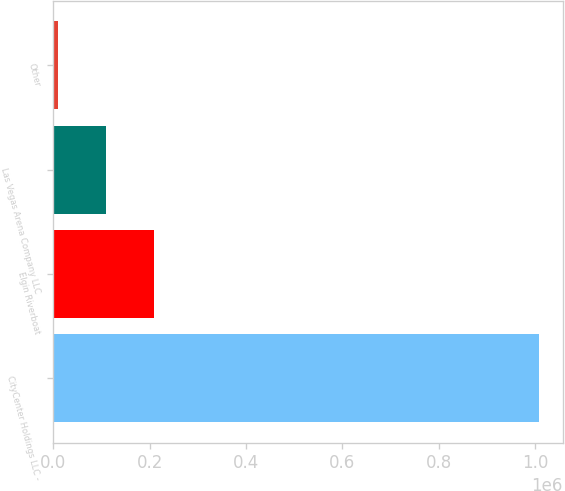Convert chart. <chart><loc_0><loc_0><loc_500><loc_500><bar_chart><fcel>CityCenter Holdings LLC -<fcel>Elgin Riverboat<fcel>Las Vegas Arena Company LLC<fcel>Other<nl><fcel>1.00736e+06<fcel>208800<fcel>108981<fcel>9161<nl></chart> 